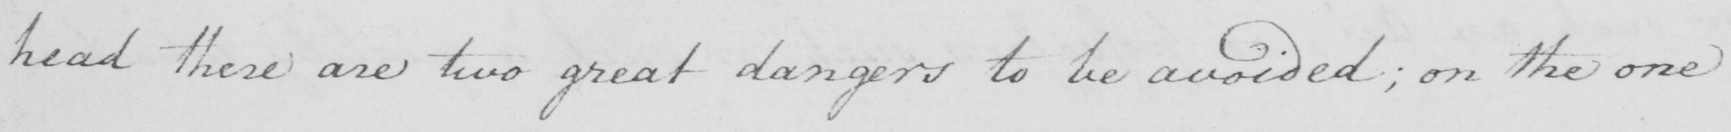Transcribe the text shown in this historical manuscript line. head these are two great dangers to be avoided ; on the one 